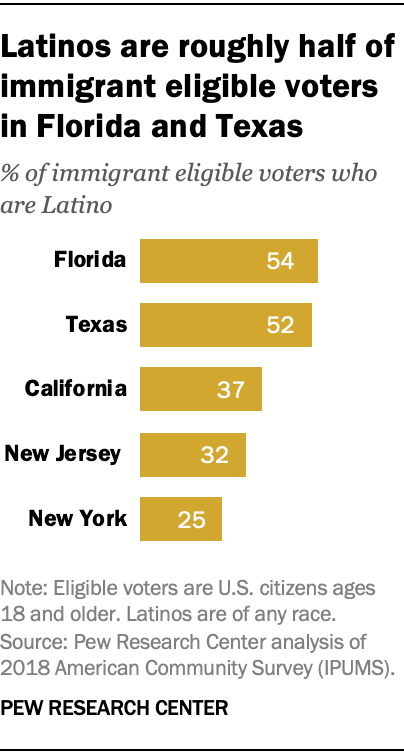Highlight a few significant elements in this photo. The value of the yellow bar in New York is 25. The median is not equal to the smallest bar. 